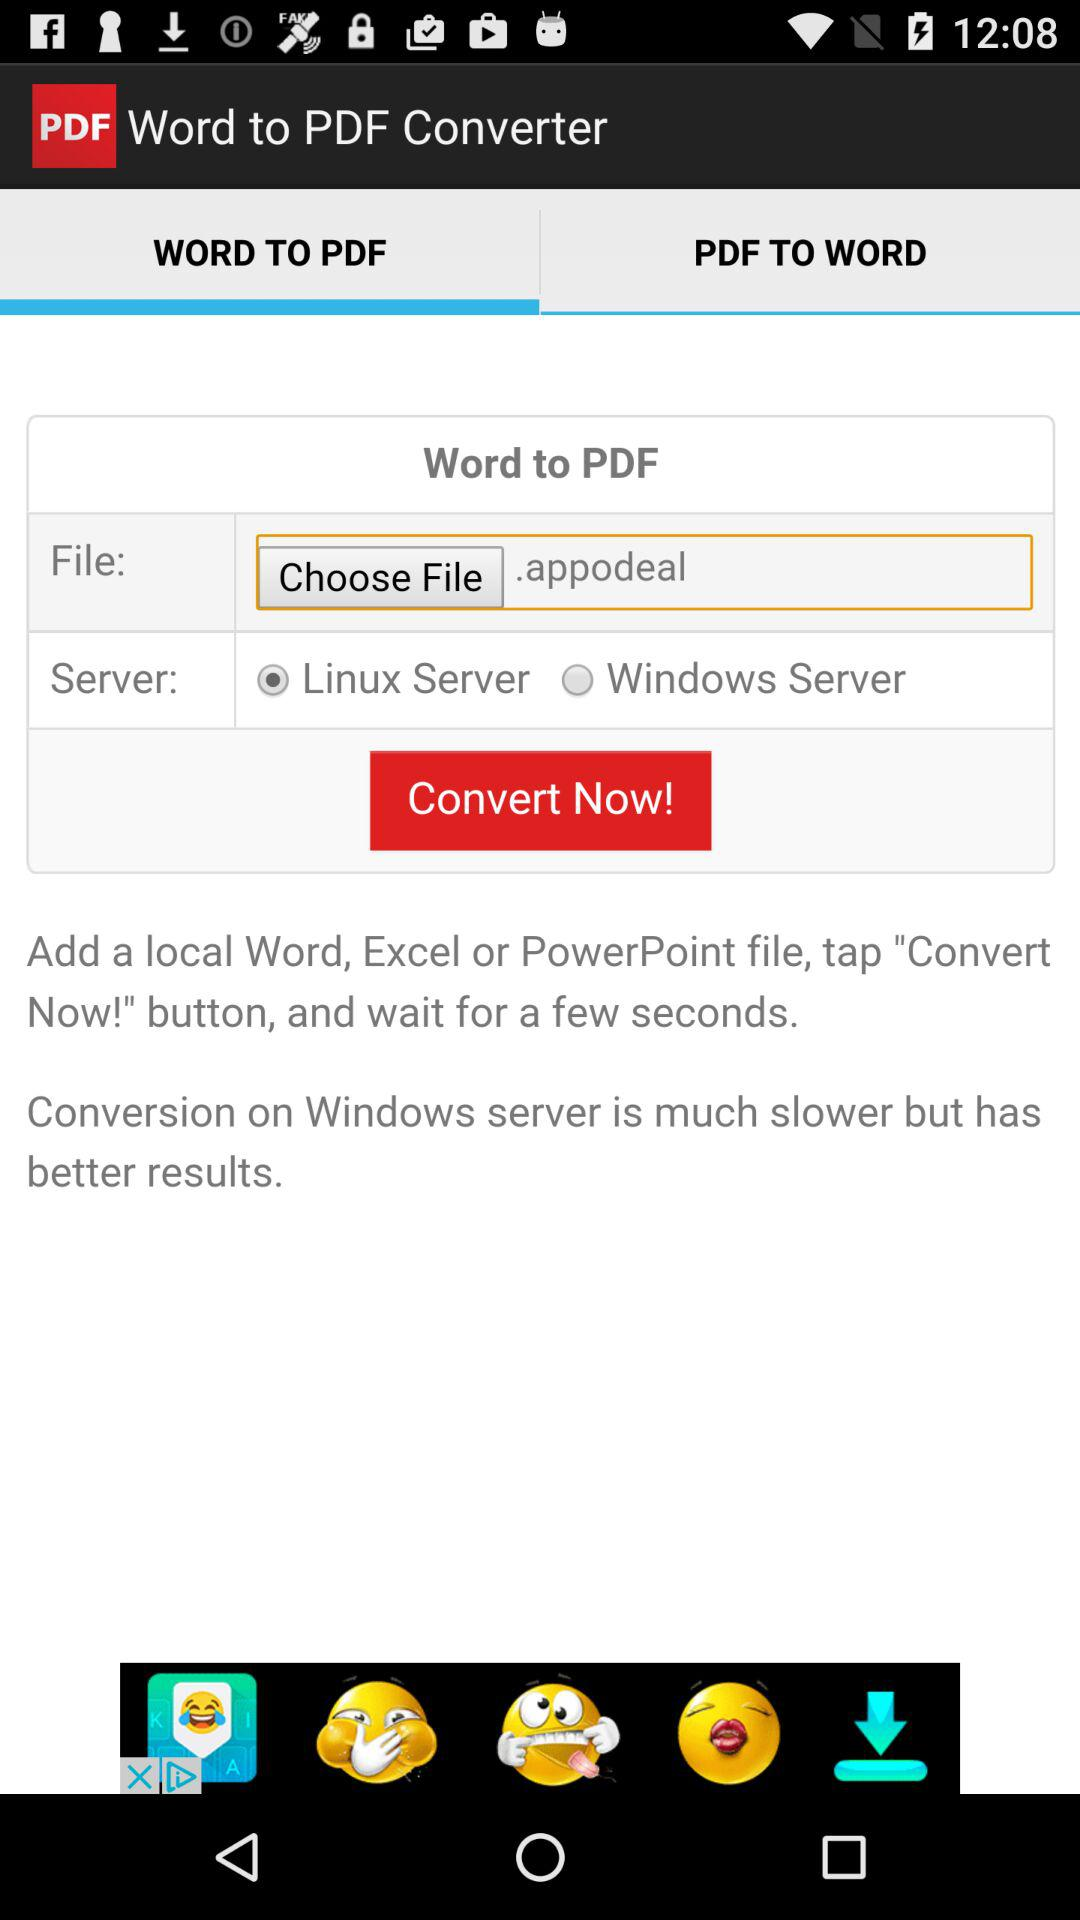Which server is selected? The selected server is "Linux Server". 